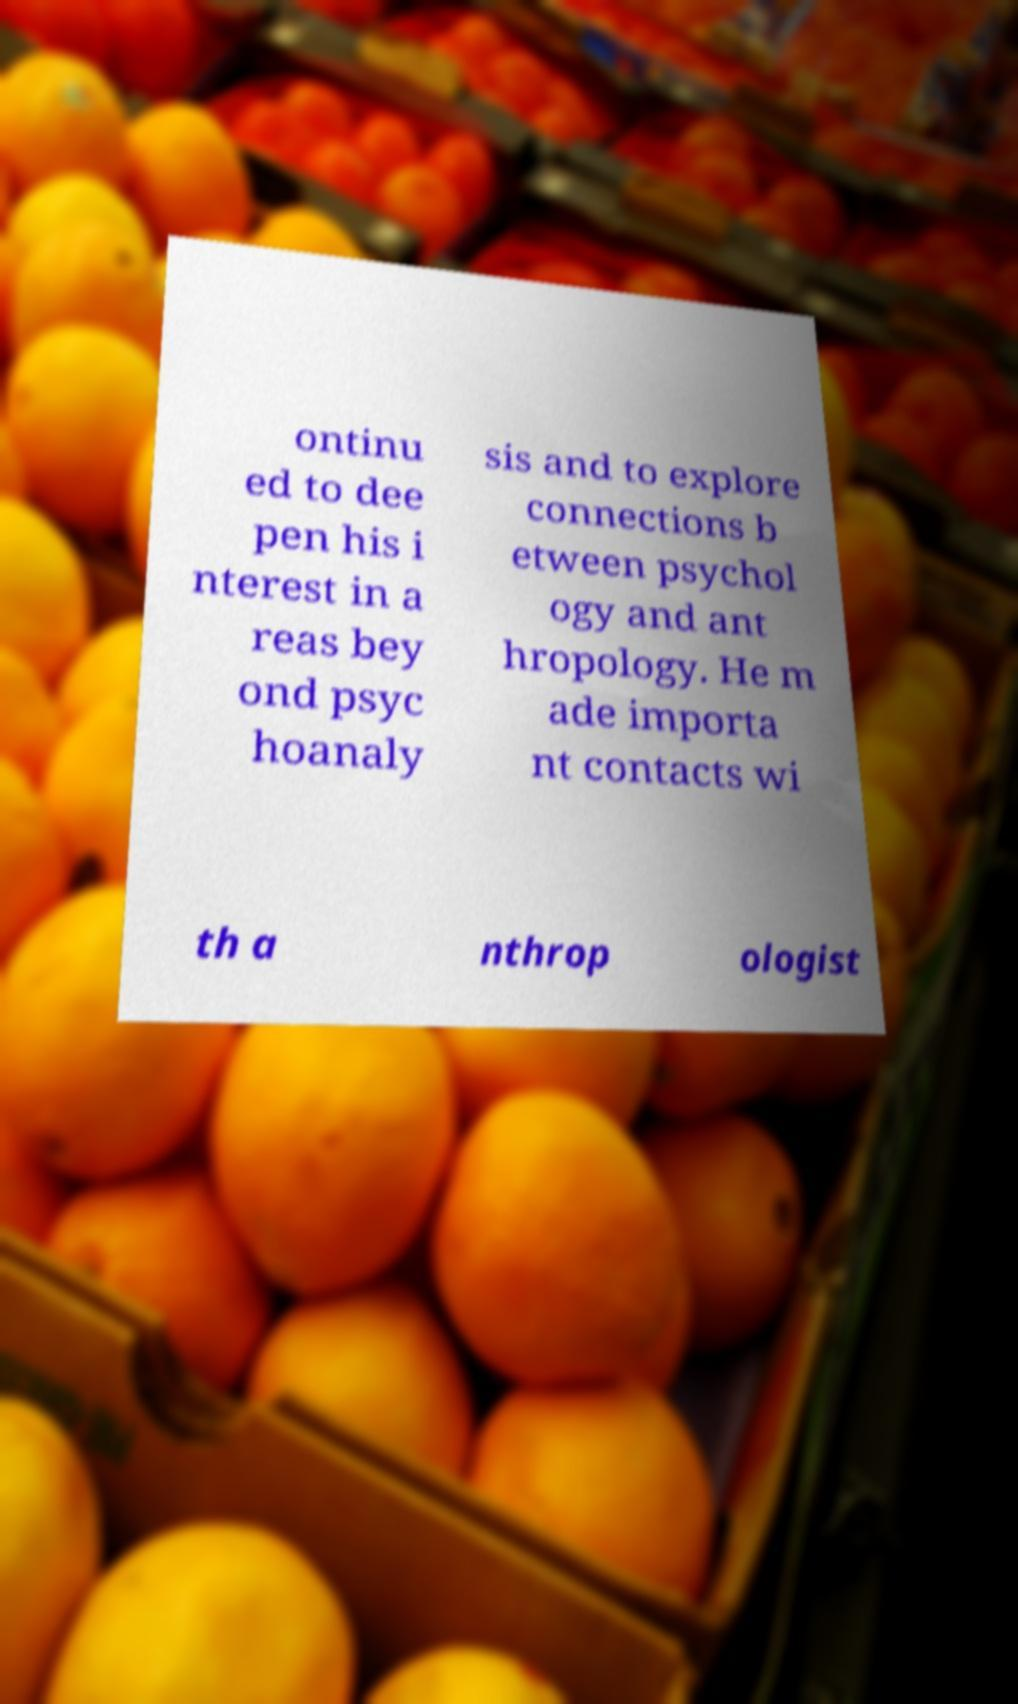Can you accurately transcribe the text from the provided image for me? ontinu ed to dee pen his i nterest in a reas bey ond psyc hoanaly sis and to explore connections b etween psychol ogy and ant hropology. He m ade importa nt contacts wi th a nthrop ologist 